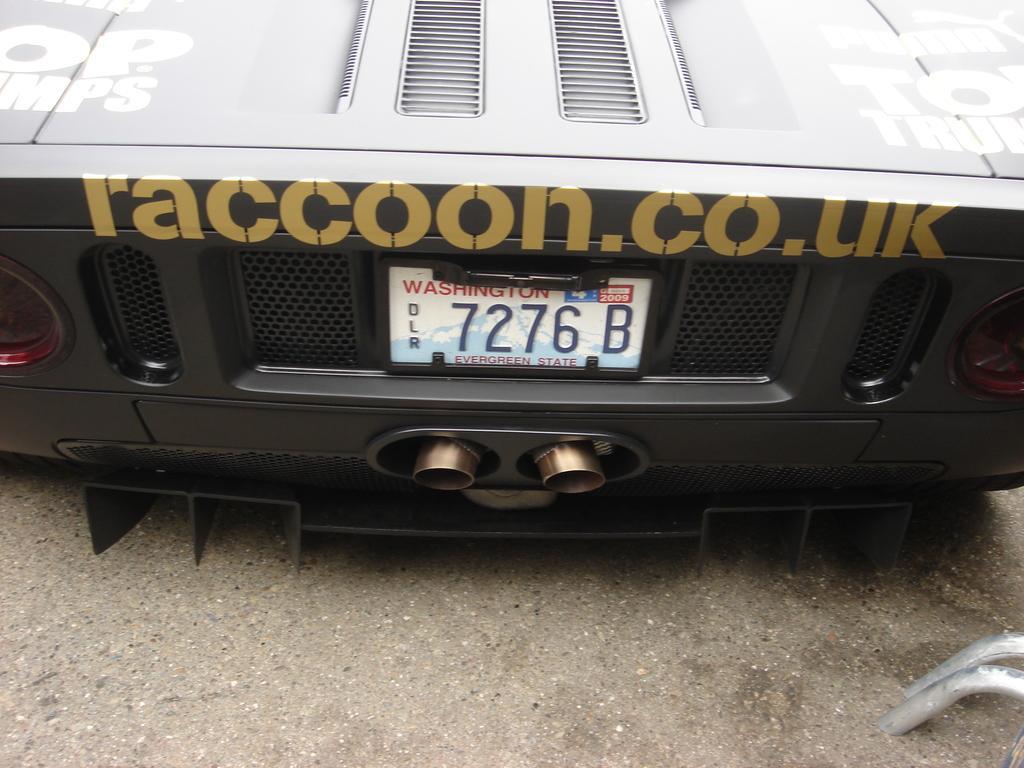Please provide a concise description of this image. In this picture we can see a car, at the right bottom of the image we can find few metal rods. 